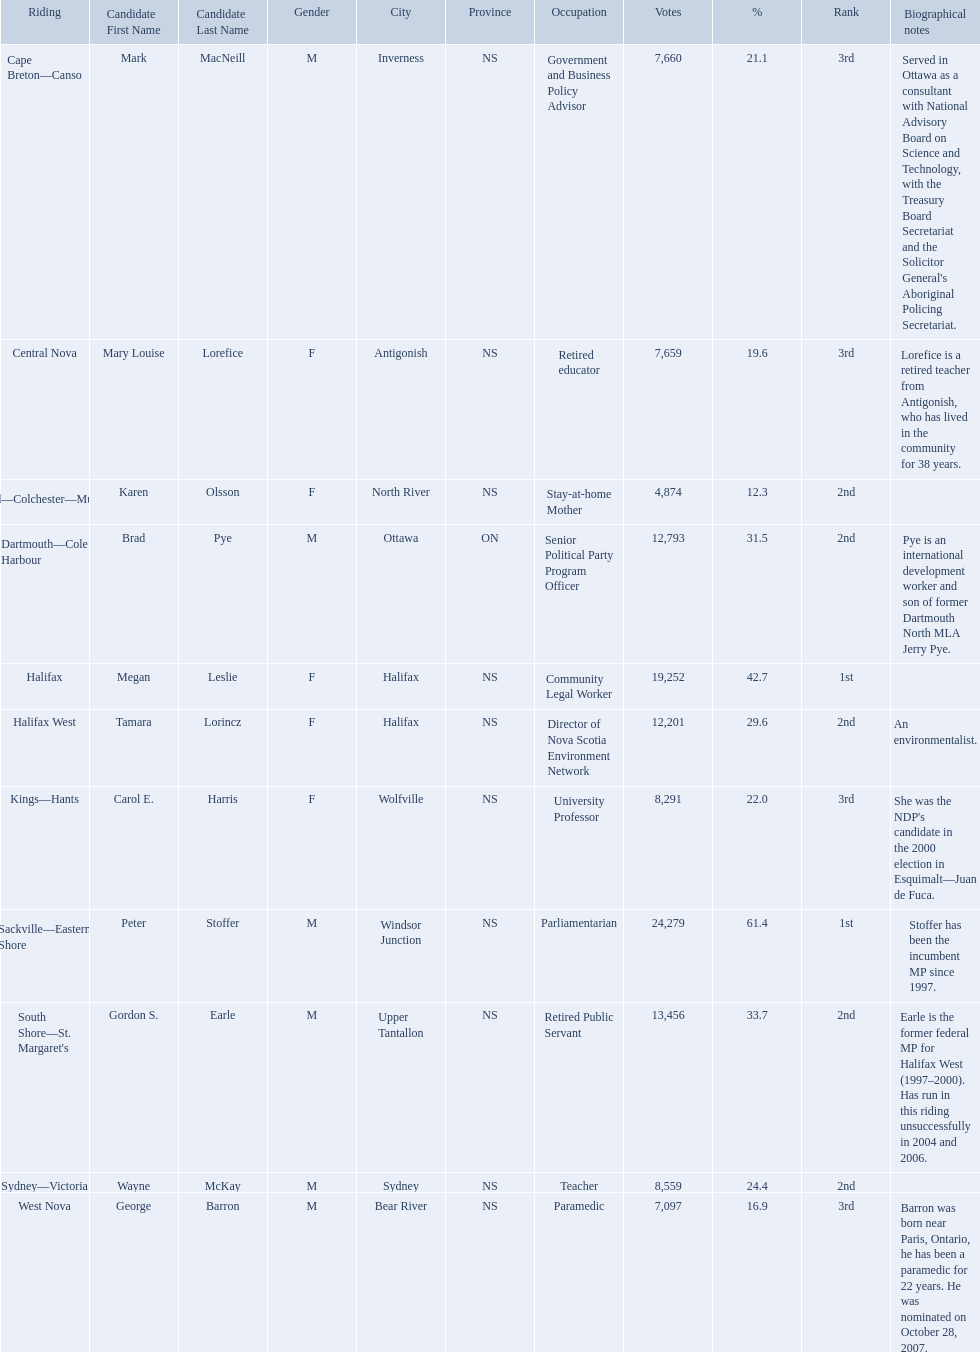How many votes did macneill receive? 7,660. How many votes did olsoon receive? 4,874. Between macneil and olsson, who received more votes? Mark MacNeill. Could you help me parse every detail presented in this table? {'header': ['Riding', 'Candidate First Name', 'Candidate Last Name', 'Gender', 'City', 'Province', 'Occupation', 'Votes', '%', 'Rank', 'Biographical notes'], 'rows': [['Cape Breton—Canso', 'Mark', 'MacNeill', 'M', 'Inverness', 'NS', 'Government and Business Policy Advisor', '7,660', '21.1', '3rd', "Served in Ottawa as a consultant with National Advisory Board on Science and Technology, with the Treasury Board Secretariat and the Solicitor General's Aboriginal Policing Secretariat."], ['Central Nova', 'Mary Louise', 'Lorefice', 'F', 'Antigonish', 'NS', 'Retired educator', '7,659', '19.6', '3rd', 'Lorefice is a retired teacher from Antigonish, who has lived in the community for 38 years.'], ['Cumberland—Colchester—Musquodoboit Valley', 'Karen', 'Olsson', 'F', 'North River', 'NS', 'Stay-at-home Mother', '4,874', '12.3', '2nd', ''], ['Dartmouth—Cole Harbour', 'Brad', 'Pye', 'M', 'Ottawa', 'ON', 'Senior Political Party Program Officer', '12,793', '31.5', '2nd', 'Pye is an international development worker and son of former Dartmouth North MLA Jerry Pye.'], ['Halifax', 'Megan', 'Leslie', 'F', 'Halifax', 'NS', 'Community Legal Worker', '19,252', '42.7', '1st', ''], ['Halifax West', 'Tamara', 'Lorincz', 'F', 'Halifax', 'NS', 'Director of Nova Scotia Environment Network', '12,201', '29.6', '2nd', 'An environmentalist.'], ['Kings—Hants', 'Carol E.', 'Harris', 'F', 'Wolfville', 'NS', 'University Professor', '8,291', '22.0', '3rd', "She was the NDP's candidate in the 2000 election in Esquimalt—Juan de Fuca."], ['Sackville—Eastern Shore', 'Peter', 'Stoffer', 'M', 'Windsor Junction', 'NS', 'Parliamentarian', '24,279', '61.4', '1st', 'Stoffer has been the incumbent MP since 1997.'], ["South Shore—St. Margaret's", 'Gordon S.', 'Earle', 'M', 'Upper Tantallon', 'NS', 'Retired Public Servant', '13,456', '33.7', '2nd', 'Earle is the former federal MP for Halifax West (1997–2000). Has run in this riding unsuccessfully in 2004 and 2006.'], ['Sydney—Victoria', 'Wayne', 'McKay', 'M', 'Sydney', 'NS', 'Teacher', '8,559', '24.4', '2nd', ''], ['West Nova', 'George', 'Barron', 'M', 'Bear River', 'NS', 'Paramedic', '7,097', '16.9', '3rd', 'Barron was born near Paris, Ontario, he has been a paramedic for 22 years. He was nominated on October 28, 2007.']]} Who were the new democratic party candidates, 2008? Mark MacNeill, Mary Louise Lorefice, Karen Olsson, Brad Pye, Megan Leslie, Tamara Lorincz, Carol E. Harris, Peter Stoffer, Gordon S. Earle, Wayne McKay, George Barron. Who had the 2nd highest number of votes? Megan Leslie, Peter Stoffer. How many votes did she receive? 19,252. Who are all the candidates? Mark MacNeill, Mary Louise Lorefice, Karen Olsson, Brad Pye, Megan Leslie, Tamara Lorincz, Carol E. Harris, Peter Stoffer, Gordon S. Earle, Wayne McKay, George Barron. How many votes did they receive? 7,660, 7,659, 4,874, 12,793, 19,252, 12,201, 8,291, 24,279, 13,456, 8,559, 7,097. And of those, how many were for megan leslie? 19,252. What new democratic party candidates ran in the 2008 canadian federal election? Mark MacNeill, Mary Louise Lorefice, Karen Olsson, Brad Pye, Megan Leslie, Tamara Lorincz, Carol E. Harris, Peter Stoffer, Gordon S. Earle, Wayne McKay, George Barron. Of these candidates, which are female? Mary Louise Lorefice, Karen Olsson, Megan Leslie, Tamara Lorincz, Carol E. Harris. Which of these candidates resides in halifax? Megan Leslie, Tamara Lorincz. Of the remaining two, which was ranked 1st? Megan Leslie. How many votes did she get? 19,252. 